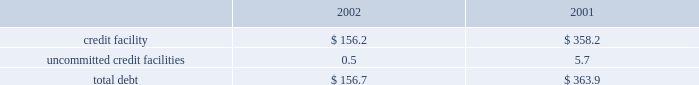Z i m m e r h o l d i n g s , i n c .
A n d s u b s i d i a r i e s 2 0 0 2 f o r m 1 0 - k notes to consolidated financial statements ( continued ) rating as of december 31 , 2002 met such requirement .
Fair value commitments under the credit facility are subject to certain the carrying value of the company 2019s borrowings approxi- fees , including a facility and a utilization fee .
Mates fair value due to their short-term maturities and uncommitted credit facilities variable interest rates .
The company has a $ 26 million uncommitted unsecured 8 .
Derivative financial instruments revolving line of credit .
The purpose of this credit line is to support the working capital needs , letters of credit and the company is exposed to market risk due to changes overdraft needs for the company .
The uncommitted credit in currency exchange rates .
As a result , the company utilizes agreement contains customary affirmative and negative cove- foreign exchange forward contracts to offset the effect of nants and events of default , none of which are considered exchange rate fluctuations on anticipated foreign currency restrictive to the operation of the business .
In addition , this transactions , primarily intercompany sales and purchases uncommitted credit agreement provides for unconditional expected to occur within the next twelve to twenty-four and irrevocable guarantees by the company .
In the event the months .
The company does not hold financial instruments company 2019s long-term debt ratings by both standard and for trading or speculative purposes .
For derivatives which poor 2019s ratings services and moody 2019s investor 2019s service , inc. , qualify as hedges of future cash flows , the effective portion fall below bb- and ba3 , then the company may be required of changes in fair value is temporarily recorded in other to repay all outstanding and contingent obligations .
The comprehensive income , then recognized in earnings when company 2019s credit rating as of december 31 , 2002 met such the hedged item affects earnings .
The ineffective portion of requirement .
This uncommitted credit line matures on a derivative 2019s change in fair value , if any , is reported in july 31 , 2003 .
Outstanding borrowings under this uncommit- earnings .
The net amount recognized in earnings during the ted line of credit as of december 31 , 2002 were $ 0.5 million years ended december 31 , 2002 and 2001 , due to ineffective- with a weighted average interest rate of 6.35 percent .
Ness and amounts excluded from the assessment of hedge the company also has a $ 15 million uncommitted effectiveness , was not significant .
Revolving unsecured line of credit .
The purpose of this line of the notional amounts of outstanding foreign exchange credit is to support short-term working capital needs of the forward contracts , principally japanese yen and the euro , company .
The agreement for this uncommitted unsecured entered into with third parties , at december 31 , 2002 , was line of credit contains customary covenants , none of which $ 252 million .
The fair value of derivative instruments recorded are considered restrictive to the operation of the business .
In accrued liabilities at december 31 , 2002 , was $ 13.8 million , this uncommitted line matures on july 31 , 2003 .
There were or $ 8.5 million net of taxes , which is deferred in other no borrowings under this uncommitted line of credit as of comprehensive income and is expected to be reclassified to december 31 , 2002 .
Earnings over the next two years , of which , $ 7.7 million , or the company has a $ 20 million uncommitted revolving $ 4.8 million , net of taxes , is expected to be reclassified to unsecured line of credit .
The purpose of this line of credit is earnings over the next twelve months .
To support short-term working capital needs of the company .
The pricing is based upon money market rates .
The agree- 9 .
Capital stock and earnings per share ment for this uncommitted unsecured line of credit contains as discussed in note 14 , all of the shares of company customary covenants , none of which are considered restrictive common stock were distributed at the distribution by the to the operation of the business .
This uncommitted line former parent to its stockholders in the form of a dividend matures on july 31 , 2003 .
There were no borrowings under of one share of company common stock , and the associated this uncommitted line of credit as of december 31 , 2002 .
Preferred stock purchase right , for every ten shares of the company was in compliance with all covenants common stock of the former parent .
In july 2001 the board under all three of the uncommitted credit facilities as of of directors of the company adopted a rights agreement december 31 , 2002 .
The company had no long-term debt intended to have anti-takeover effects .
Under this agreement as of december 31 , 2002 .
One right attaches to each share of company common stock .
Outstanding debt as of december 31 , 2002 and 2001 , the rights will not become exercisable until the earlier of : consist of the following ( in millions ) : a ) the company learns that a person or group acquired , or 2002 2001 obtained the right to acquire , beneficial ownership of securi- credit facility $ 156.2 $ 358.2 ties representing more than 20 percent of the shares of uncommitted credit facilities 0.5 5.7 company common stock then outstanding , or b ) such date , if any , as may be designated by the board of directorstotal debt $ 156.7 $ 363.9 following the commencement of , or first public disclosure of the company paid $ 13.0 million and $ 4.6 million in an intention to commence , a tender offer or exchange offer interest charges during 2002 and 2001 , respectively. .
Z i m m e r h o l d i n g s , i n c .
A n d s u b s i d i a r i e s 2 0 0 2 f o r m 1 0 - k notes to consolidated financial statements ( continued ) rating as of december 31 , 2002 met such requirement .
Fair value commitments under the credit facility are subject to certain the carrying value of the company 2019s borrowings approxi- fees , including a facility and a utilization fee .
Mates fair value due to their short-term maturities and uncommitted credit facilities variable interest rates .
The company has a $ 26 million uncommitted unsecured 8 .
Derivative financial instruments revolving line of credit .
The purpose of this credit line is to support the working capital needs , letters of credit and the company is exposed to market risk due to changes overdraft needs for the company .
The uncommitted credit in currency exchange rates .
As a result , the company utilizes agreement contains customary affirmative and negative cove- foreign exchange forward contracts to offset the effect of nants and events of default , none of which are considered exchange rate fluctuations on anticipated foreign currency restrictive to the operation of the business .
In addition , this transactions , primarily intercompany sales and purchases uncommitted credit agreement provides for unconditional expected to occur within the next twelve to twenty-four and irrevocable guarantees by the company .
In the event the months .
The company does not hold financial instruments company 2019s long-term debt ratings by both standard and for trading or speculative purposes .
For derivatives which poor 2019s ratings services and moody 2019s investor 2019s service , inc. , qualify as hedges of future cash flows , the effective portion fall below bb- and ba3 , then the company may be required of changes in fair value is temporarily recorded in other to repay all outstanding and contingent obligations .
The comprehensive income , then recognized in earnings when company 2019s credit rating as of december 31 , 2002 met such the hedged item affects earnings .
The ineffective portion of requirement .
This uncommitted credit line matures on a derivative 2019s change in fair value , if any , is reported in july 31 , 2003 .
Outstanding borrowings under this uncommit- earnings .
The net amount recognized in earnings during the ted line of credit as of december 31 , 2002 were $ 0.5 million years ended december 31 , 2002 and 2001 , due to ineffective- with a weighted average interest rate of 6.35 percent .
Ness and amounts excluded from the assessment of hedge the company also has a $ 15 million uncommitted effectiveness , was not significant .
Revolving unsecured line of credit .
The purpose of this line of the notional amounts of outstanding foreign exchange credit is to support short-term working capital needs of the forward contracts , principally japanese yen and the euro , company .
The agreement for this uncommitted unsecured entered into with third parties , at december 31 , 2002 , was line of credit contains customary covenants , none of which $ 252 million .
The fair value of derivative instruments recorded are considered restrictive to the operation of the business .
In accrued liabilities at december 31 , 2002 , was $ 13.8 million , this uncommitted line matures on july 31 , 2003 .
There were or $ 8.5 million net of taxes , which is deferred in other no borrowings under this uncommitted line of credit as of comprehensive income and is expected to be reclassified to december 31 , 2002 .
Earnings over the next two years , of which , $ 7.7 million , or the company has a $ 20 million uncommitted revolving $ 4.8 million , net of taxes , is expected to be reclassified to unsecured line of credit .
The purpose of this line of credit is earnings over the next twelve months .
To support short-term working capital needs of the company .
The pricing is based upon money market rates .
The agree- 9 .
Capital stock and earnings per share ment for this uncommitted unsecured line of credit contains as discussed in note 14 , all of the shares of company customary covenants , none of which are considered restrictive common stock were distributed at the distribution by the to the operation of the business .
This uncommitted line former parent to its stockholders in the form of a dividend matures on july 31 , 2003 .
There were no borrowings under of one share of company common stock , and the associated this uncommitted line of credit as of december 31 , 2002 .
Preferred stock purchase right , for every ten shares of the company was in compliance with all covenants common stock of the former parent .
In july 2001 the board under all three of the uncommitted credit facilities as of of directors of the company adopted a rights agreement december 31 , 2002 .
The company had no long-term debt intended to have anti-takeover effects .
Under this agreement as of december 31 , 2002 .
One right attaches to each share of company common stock .
Outstanding debt as of december 31 , 2002 and 2001 , the rights will not become exercisable until the earlier of : consist of the following ( in millions ) : a ) the company learns that a person or group acquired , or 2002 2001 obtained the right to acquire , beneficial ownership of securi- credit facility $ 156.2 $ 358.2 ties representing more than 20 percent of the shares of uncommitted credit facilities 0.5 5.7 company common stock then outstanding , or b ) such date , if any , as may be designated by the board of directorstotal debt $ 156.7 $ 363.9 following the commencement of , or first public disclosure of the company paid $ 13.0 million and $ 4.6 million in an intention to commence , a tender offer or exchange offer interest charges during 2002 and 2001 , respectively. .
What percent of the total debt is in the 2002 debt balance? 
Computations: (156.7 / (156.7 + 363.9))
Answer: 0.301. 